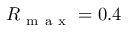Convert formula to latex. <formula><loc_0><loc_0><loc_500><loc_500>R _ { m a x } = 0 . 4</formula> 